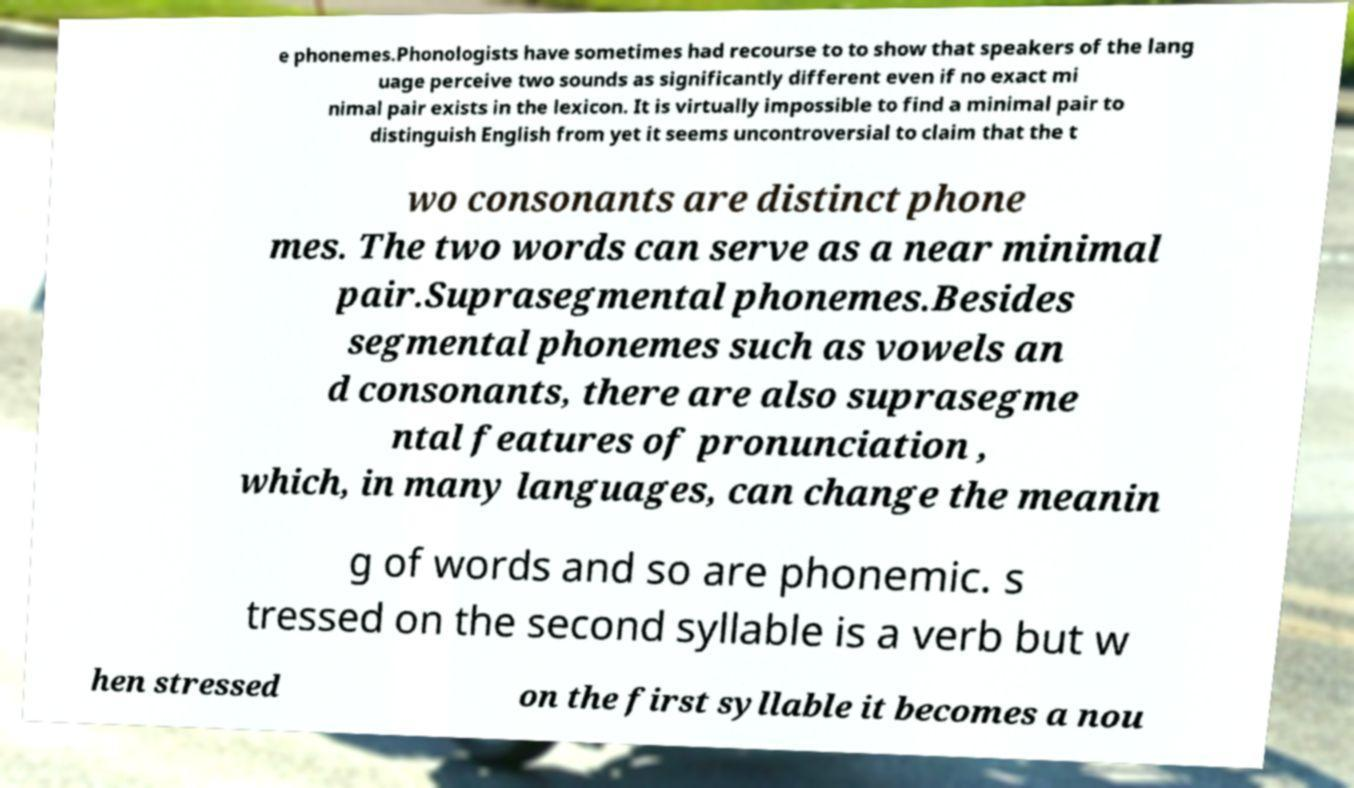Please identify and transcribe the text found in this image. e phonemes.Phonologists have sometimes had recourse to to show that speakers of the lang uage perceive two sounds as significantly different even if no exact mi nimal pair exists in the lexicon. It is virtually impossible to find a minimal pair to distinguish English from yet it seems uncontroversial to claim that the t wo consonants are distinct phone mes. The two words can serve as a near minimal pair.Suprasegmental phonemes.Besides segmental phonemes such as vowels an d consonants, there are also suprasegme ntal features of pronunciation , which, in many languages, can change the meanin g of words and so are phonemic. s tressed on the second syllable is a verb but w hen stressed on the first syllable it becomes a nou 